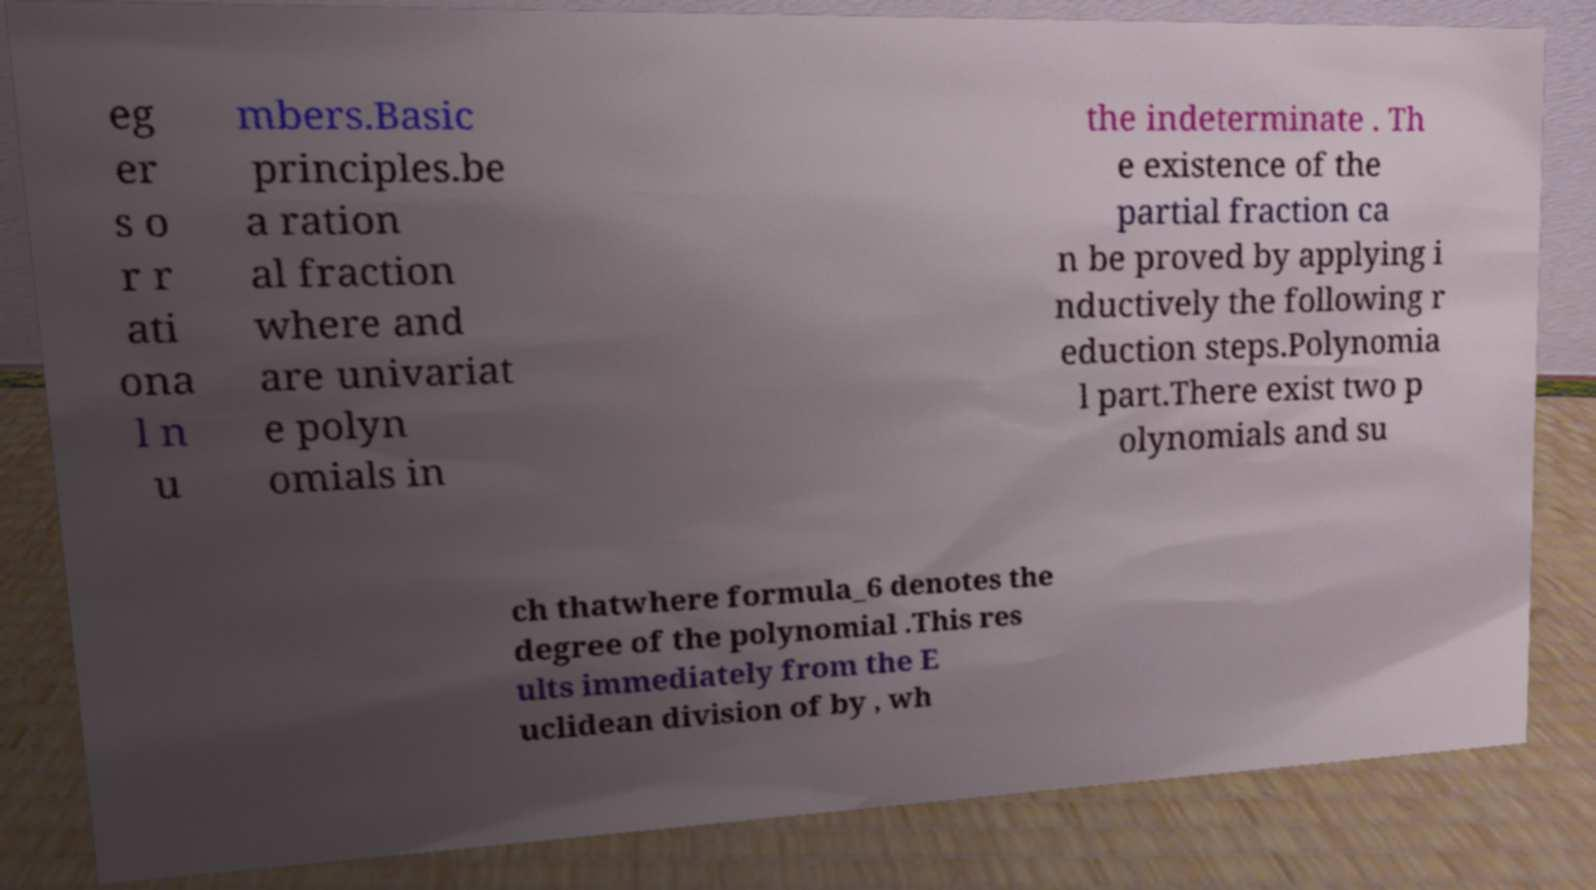Please read and relay the text visible in this image. What does it say? eg er s o r r ati ona l n u mbers.Basic principles.be a ration al fraction where and are univariat e polyn omials in the indeterminate . Th e existence of the partial fraction ca n be proved by applying i nductively the following r eduction steps.Polynomia l part.There exist two p olynomials and su ch thatwhere formula_6 denotes the degree of the polynomial .This res ults immediately from the E uclidean division of by , wh 